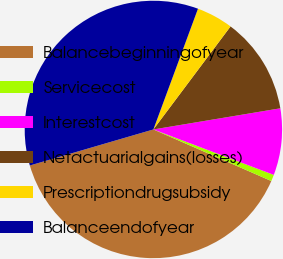Convert chart to OTSL. <chart><loc_0><loc_0><loc_500><loc_500><pie_chart><fcel>Balancebeginningofyear<fcel>Servicecost<fcel>Interestcost<fcel>Netactuarialgains(losses)<fcel>Prescriptiondrugsubsidy<fcel>Balanceendofyear<nl><fcel>38.92%<fcel>0.82%<fcel>8.37%<fcel>12.14%<fcel>4.6%<fcel>35.15%<nl></chart> 